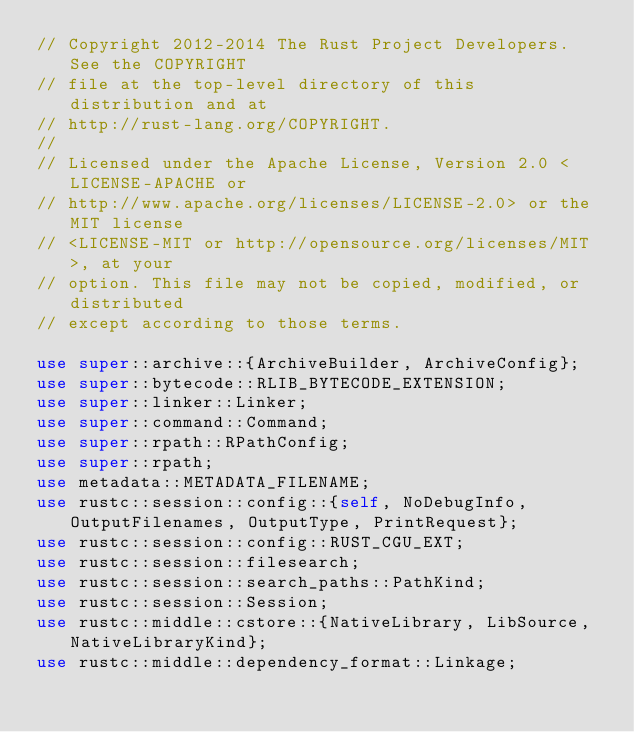<code> <loc_0><loc_0><loc_500><loc_500><_Rust_>// Copyright 2012-2014 The Rust Project Developers. See the COPYRIGHT
// file at the top-level directory of this distribution and at
// http://rust-lang.org/COPYRIGHT.
//
// Licensed under the Apache License, Version 2.0 <LICENSE-APACHE or
// http://www.apache.org/licenses/LICENSE-2.0> or the MIT license
// <LICENSE-MIT or http://opensource.org/licenses/MIT>, at your
// option. This file may not be copied, modified, or distributed
// except according to those terms.

use super::archive::{ArchiveBuilder, ArchiveConfig};
use super::bytecode::RLIB_BYTECODE_EXTENSION;
use super::linker::Linker;
use super::command::Command;
use super::rpath::RPathConfig;
use super::rpath;
use metadata::METADATA_FILENAME;
use rustc::session::config::{self, NoDebugInfo, OutputFilenames, OutputType, PrintRequest};
use rustc::session::config::RUST_CGU_EXT;
use rustc::session::filesearch;
use rustc::session::search_paths::PathKind;
use rustc::session::Session;
use rustc::middle::cstore::{NativeLibrary, LibSource, NativeLibraryKind};
use rustc::middle::dependency_format::Linkage;</code> 